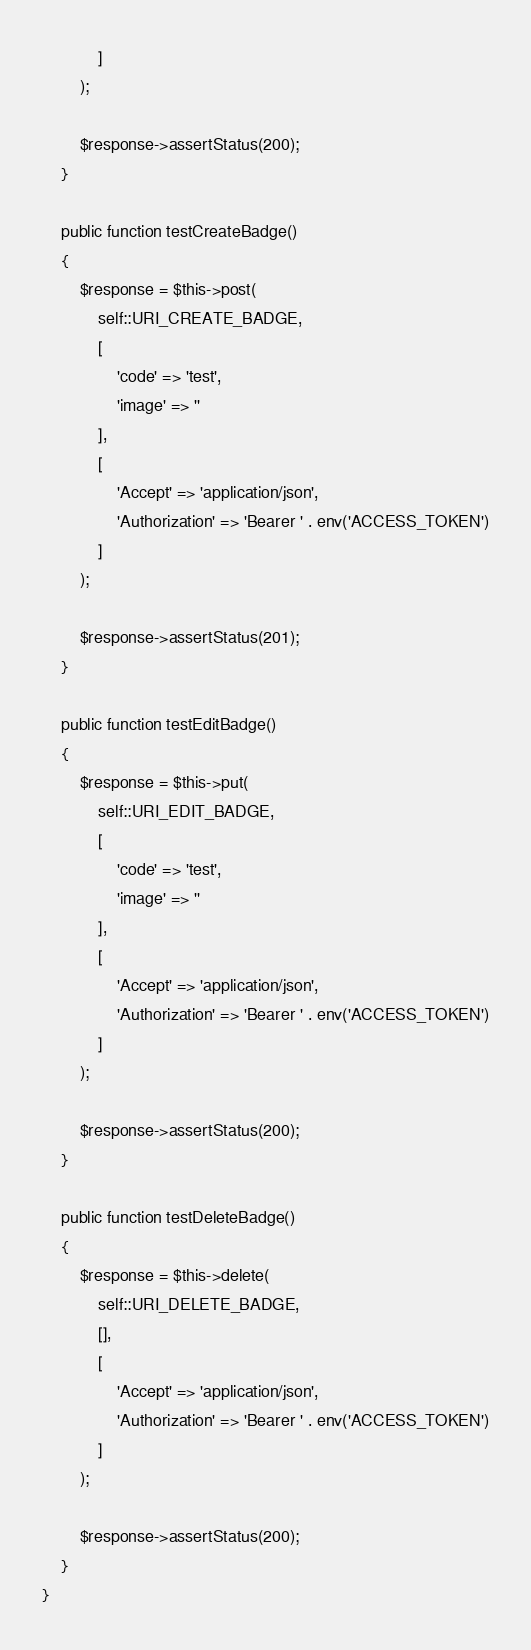<code> <loc_0><loc_0><loc_500><loc_500><_PHP_>            ]
        );

        $response->assertStatus(200);
    }

    public function testCreateBadge()
    {
        $response = $this->post(
            self::URI_CREATE_BADGE,
            [
                'code' => 'test',
                'image' => ''
            ],
            [
                'Accept' => 'application/json',
                'Authorization' => 'Bearer ' . env('ACCESS_TOKEN')
            ]
        );

        $response->assertStatus(201);
    }

    public function testEditBadge()
    {
        $response = $this->put(
            self::URI_EDIT_BADGE,
            [
                'code' => 'test',
                'image' => ''
            ],
            [
                'Accept' => 'application/json',
                'Authorization' => 'Bearer ' . env('ACCESS_TOKEN')
            ]
        );

        $response->assertStatus(200);
    }

    public function testDeleteBadge()
    {
        $response = $this->delete(
            self::URI_DELETE_BADGE,
            [],
            [
                'Accept' => 'application/json',
                'Authorization' => 'Bearer ' . env('ACCESS_TOKEN')
            ]
        );

        $response->assertStatus(200);
    }
}
</code> 